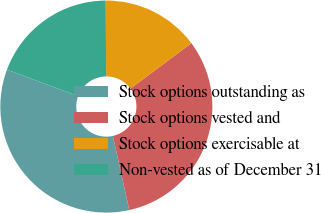<chart> <loc_0><loc_0><loc_500><loc_500><pie_chart><fcel>Stock options outstanding as<fcel>Stock options vested and<fcel>Stock options exercisable at<fcel>Non-vested as of December 31<nl><fcel>34.14%<fcel>31.72%<fcel>14.9%<fcel>19.24%<nl></chart> 